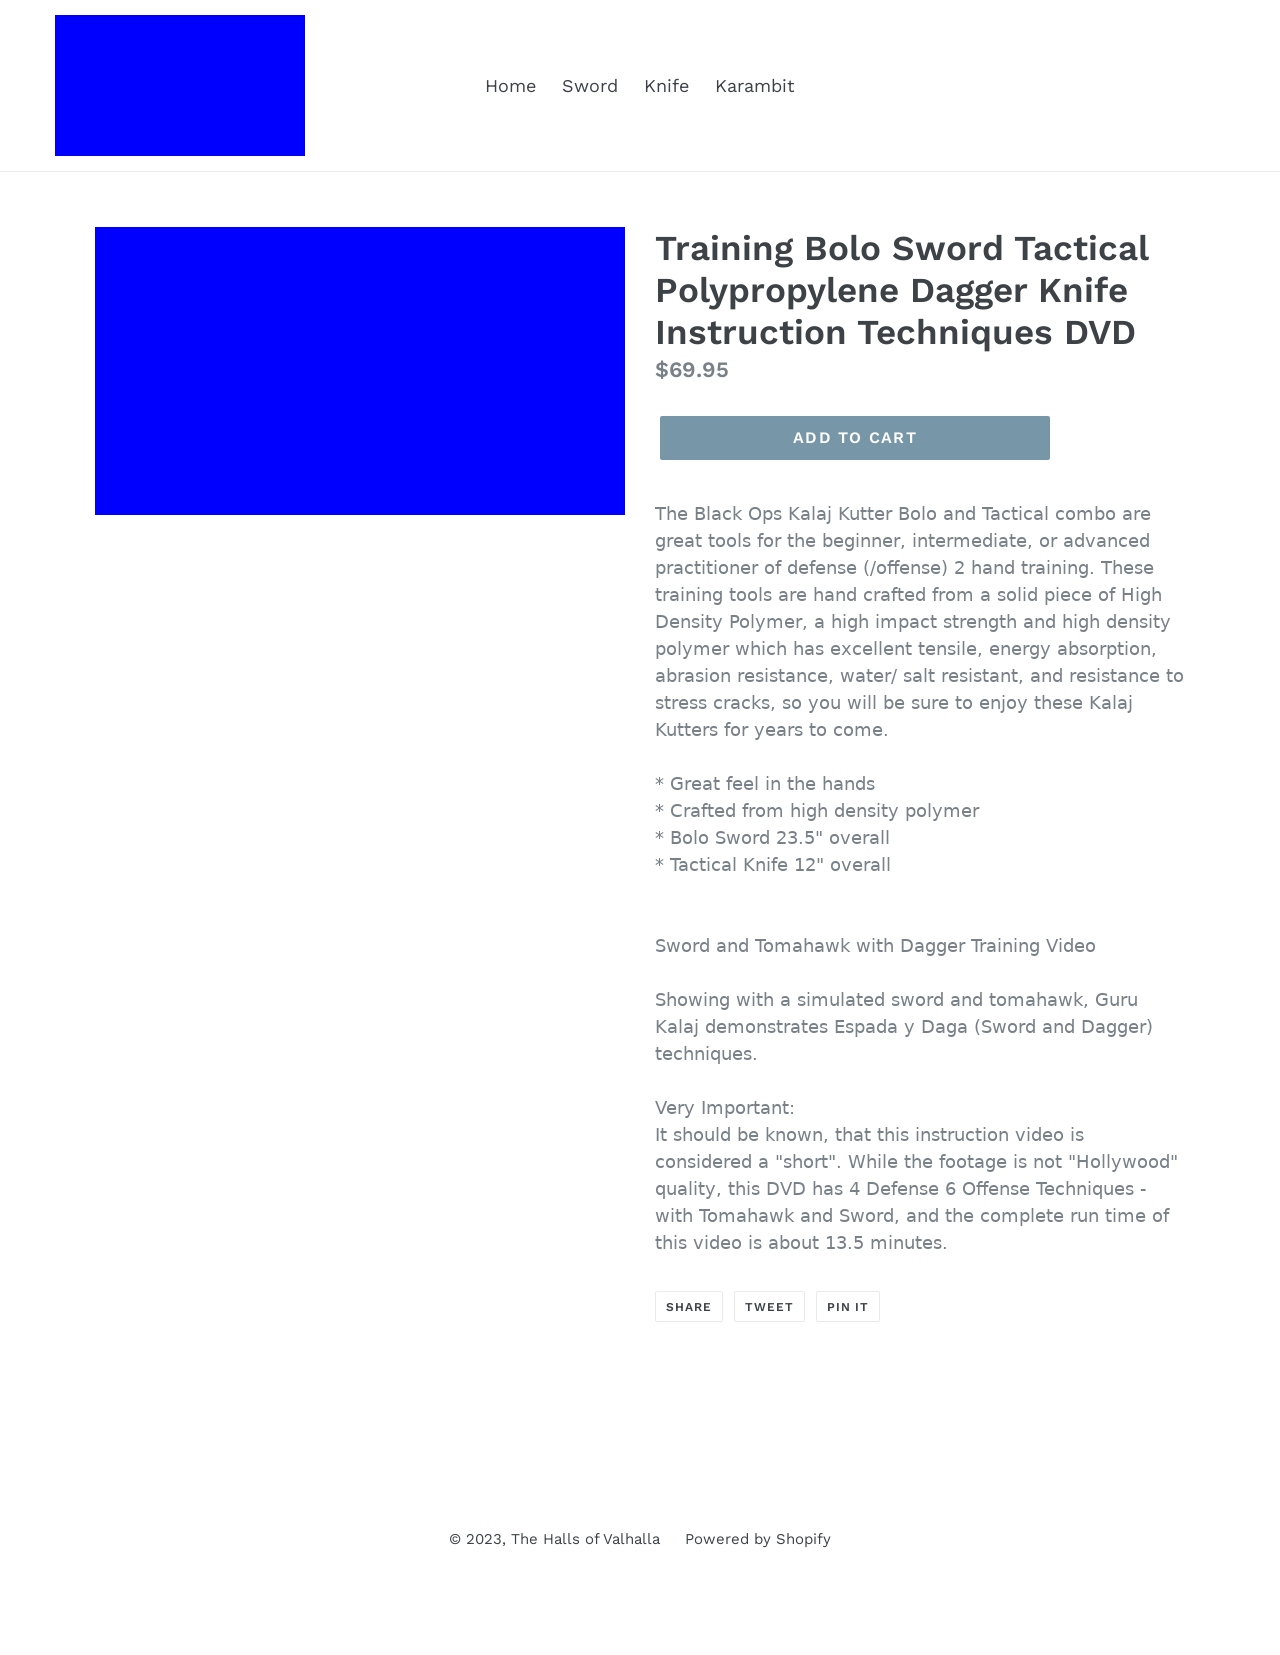Can you explain who Guru Kalaj is based on the information connected to this product? Guru Kalaj is likely a martial arts instructor or expert affiliated with the training techniques covered in the DVD. He appears to specialize in Espada y Daga, a traditional sword and dagger fighting style, indicating his expertise in Filipino martial arts. His demonstrations on the DVD provide viewers with practical knowledge and techniques, enhancing their training in Sword and Dagger tactics.  What are the cinematic qualities of the instructional DVD mentioned? The DVD is noted to be of non-'Hollywood' quality, suggesting that it focuses more on the content and educational value rather than high-production visuals. This approach is often more direct and less dramatized, aiming to provide clear, straightforward instruction to learners without the distraction of elaborate cinematic effects. 